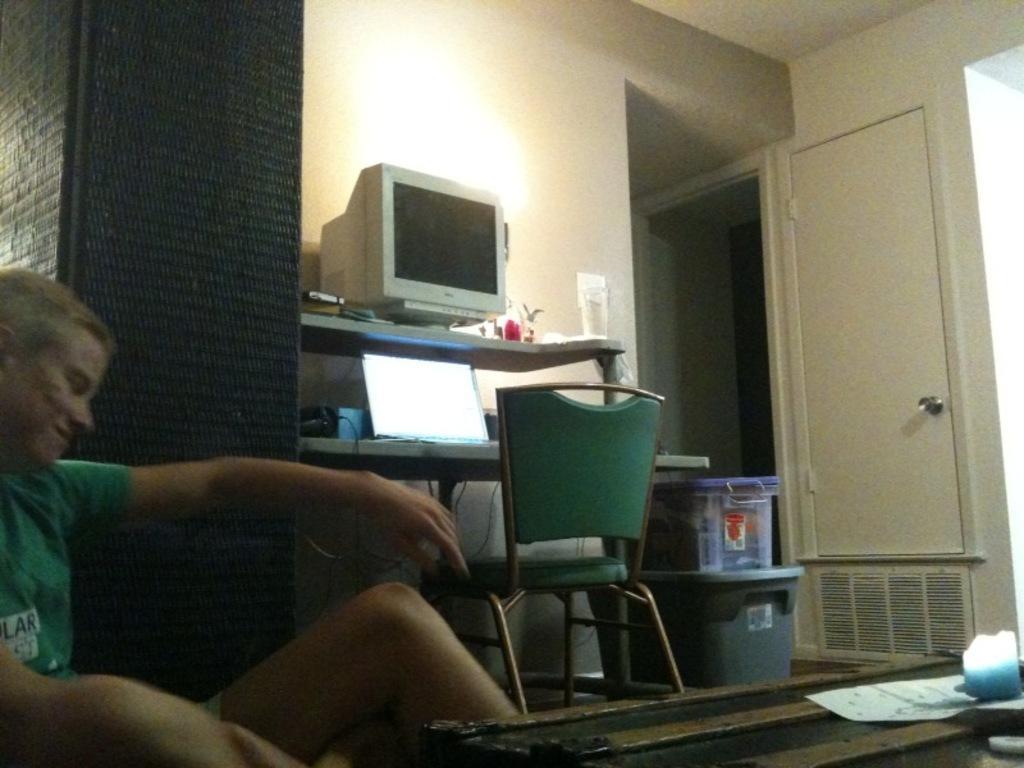How would you summarize this image in a sentence or two? In this picture there is a man on the left side of the image and there is a table at the bottom side of the image and there is a rack in the center of the image, on which there is a laptop and a monitor, there is a chair in front of the rack and there are two boxes beside the rack and there is a door in the background area of the image. 